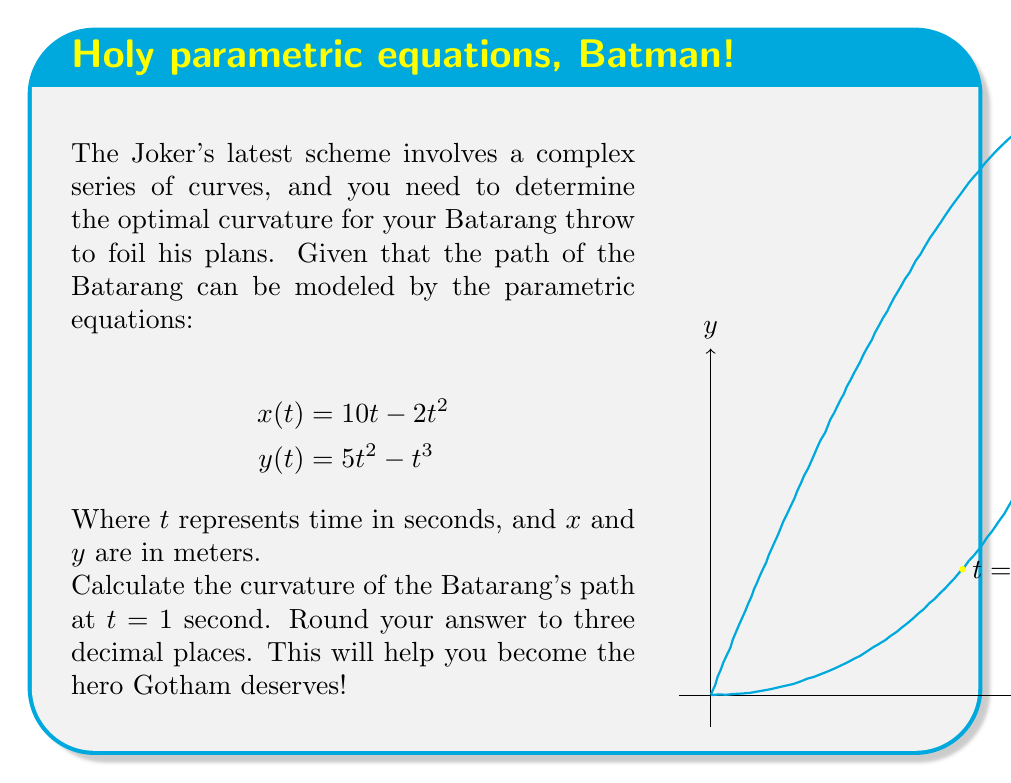Can you answer this question? Let's tackle this problem step by step, just like how Batman methodically takes down his foes:

1) To calculate the curvature, we'll use the formula:

   $$\kappa = \frac{|x'y'' - y'x''|}{(x'^2 + y'^2)^{3/2}}$$

2) First, we need to find $x'$, $y'$, $x''$, and $y''$:
   
   $x' = \frac{dx}{dt} = 10 - 4t$
   $y' = \frac{dy}{dt} = 10t - 3t^2$
   $x'' = \frac{d^2x}{dt^2} = -4$
   $y'' = \frac{d^2y}{dt^2} = 10 - 6t$

3) Now, let's evaluate these at $t = 1$:
   
   $x'(1) = 10 - 4(1) = 6$
   $y'(1) = 10(1) - 3(1)^2 = 7$
   $x''(1) = -4$
   $y''(1) = 10 - 6(1) = 4$

4) Plugging these into our curvature formula:

   $$\kappa = \frac{|6(4) - 7(-4)|}{(6^2 + 7^2)^{3/2}}$$

5) Simplifying:

   $$\kappa = \frac{|24 + 28|}{(36 + 49)^{3/2}} = \frac{52}{85^{3/2}}$$

6) Calculating and rounding to three decimal places:

   $$\kappa \approx 0.073$$

And there you have it! The optimal curvature for your Batarang throw, ready to save Gotham once again!
Answer: $0.073$ 